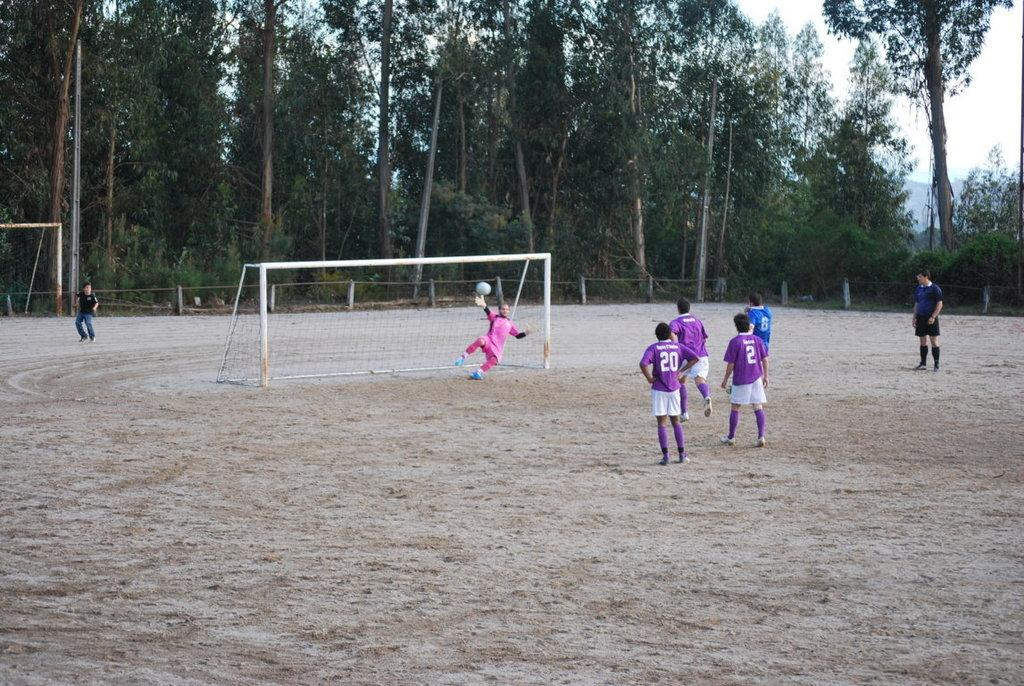<image>
Describe the image concisely. Two players wearing the numbers 20 and 2 watching someone block a goal. 